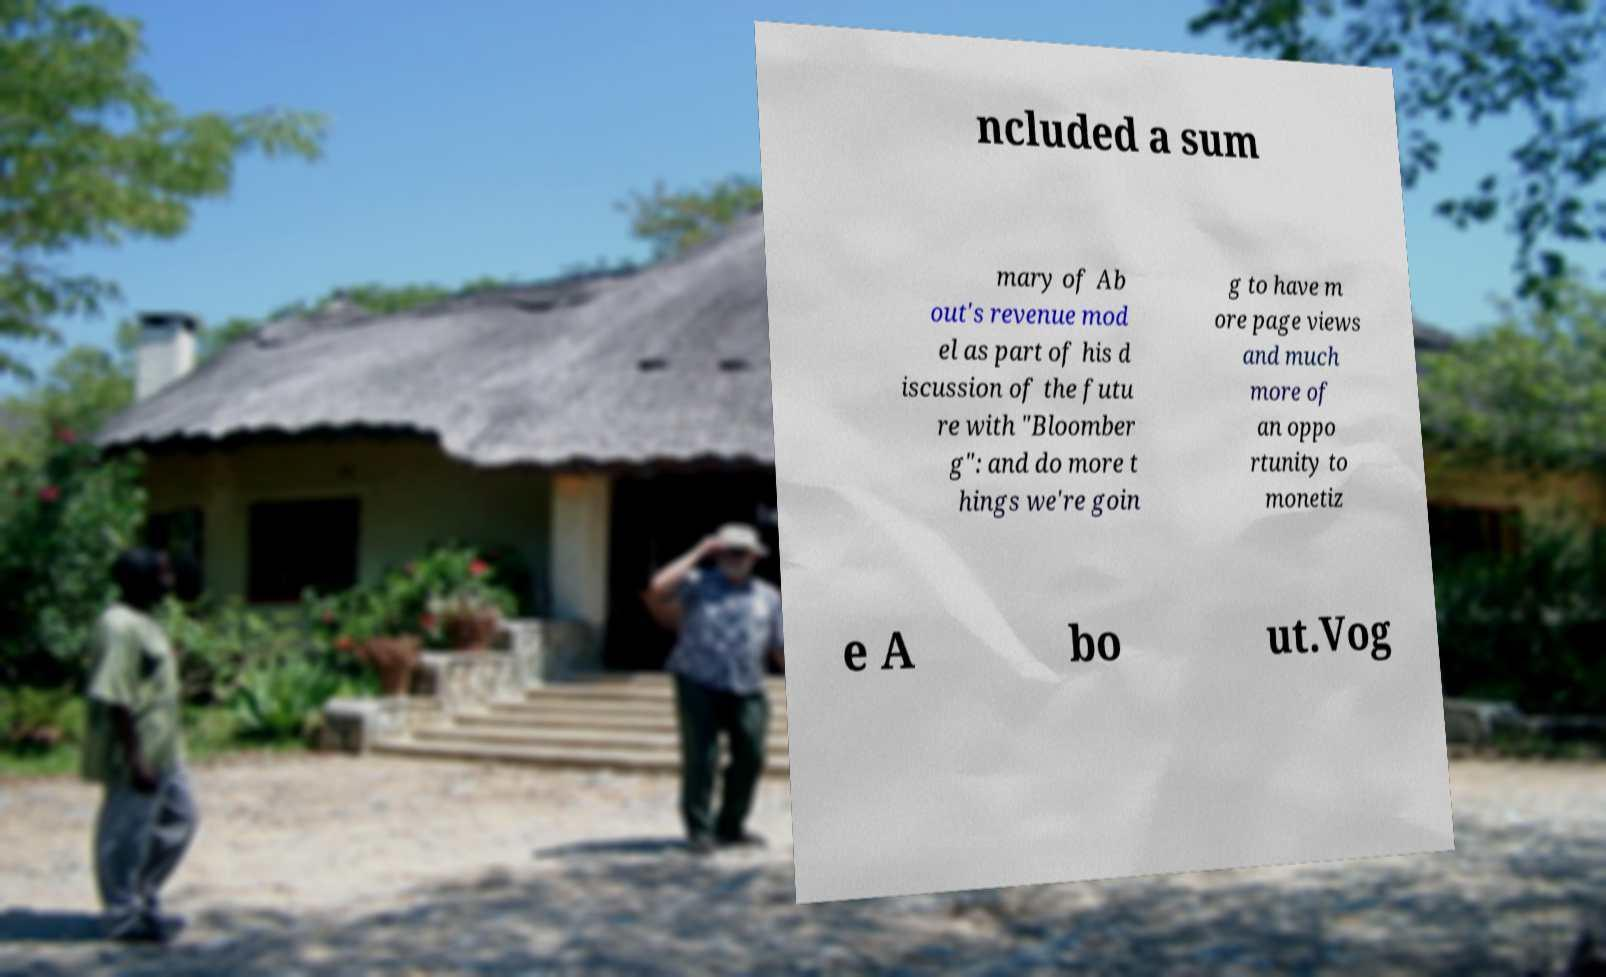Can you read and provide the text displayed in the image?This photo seems to have some interesting text. Can you extract and type it out for me? ncluded a sum mary of Ab out's revenue mod el as part of his d iscussion of the futu re with "Bloomber g": and do more t hings we're goin g to have m ore page views and much more of an oppo rtunity to monetiz e A bo ut.Vog 